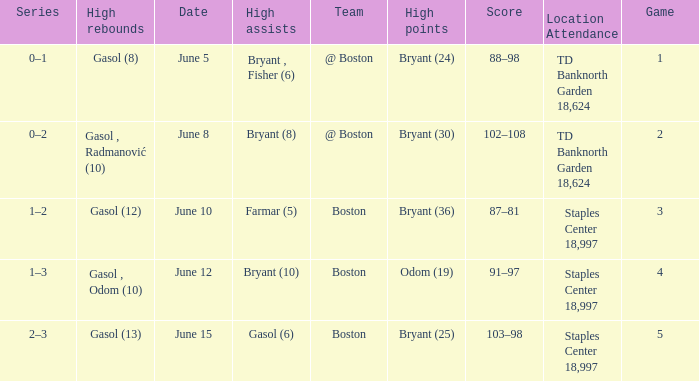Name the number of games on june 12 1.0. 